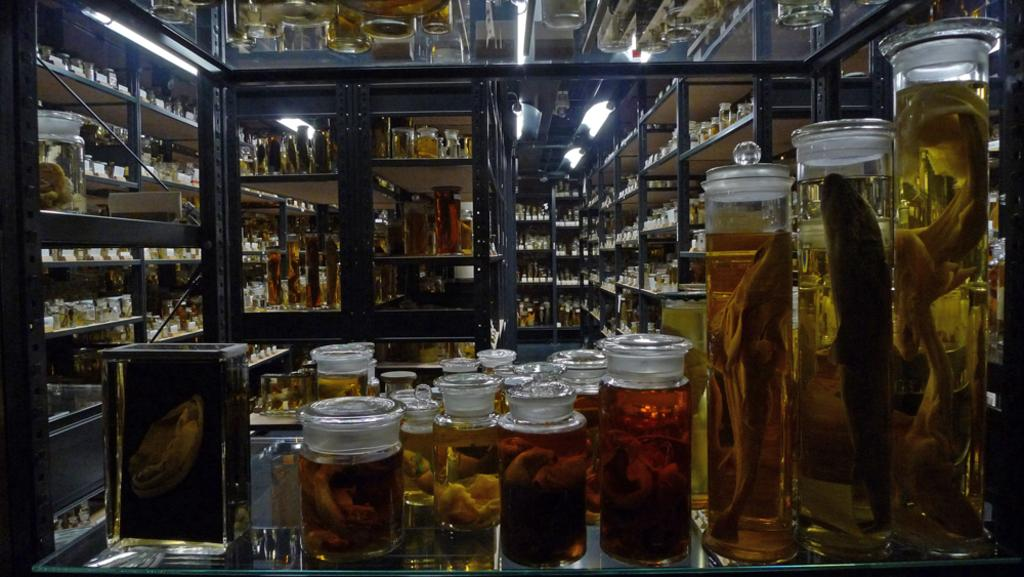What type of animals can be seen in the image? There are sea creatures in the image. How are the sea creatures contained in the image? The sea creatures are inside glass jars. What type of fruit is displayed on the shelf in the image? There is no fruit or shelf present in the image; it features sea creatures inside glass jars. 